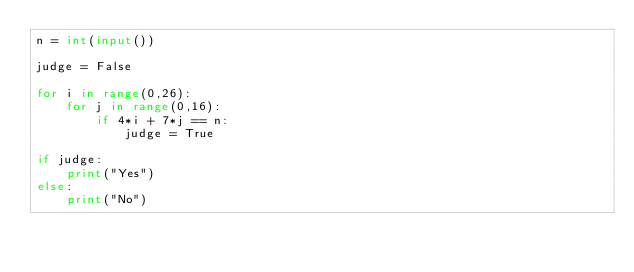<code> <loc_0><loc_0><loc_500><loc_500><_Python_>n = int(input())

judge = False

for i in range(0,26):
    for j in range(0,16):
        if 4*i + 7*j == n:
            judge = True

if judge:
    print("Yes")
else:
    print("No")</code> 